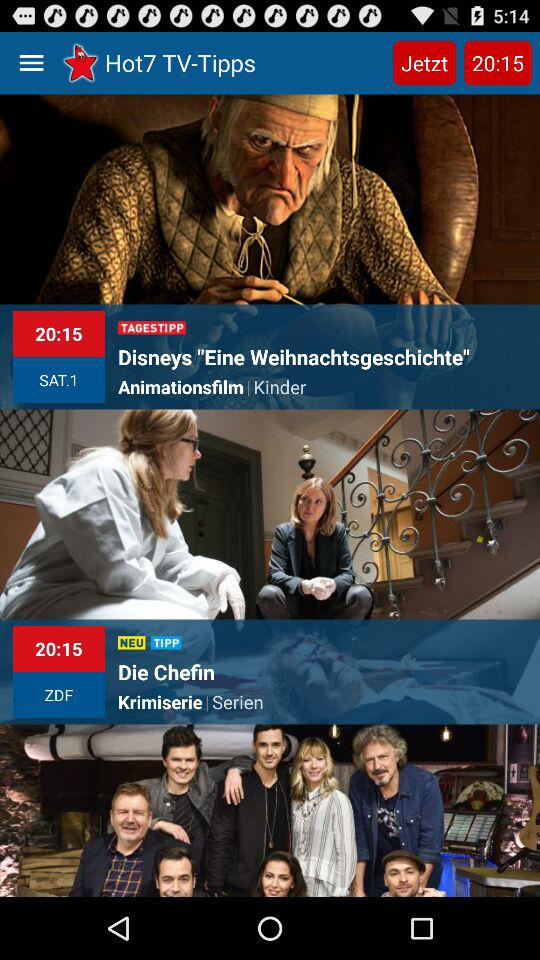What is the name of an animated film? The name of an animated film is "Disneys Eine Weihnachtsgeschichte". 